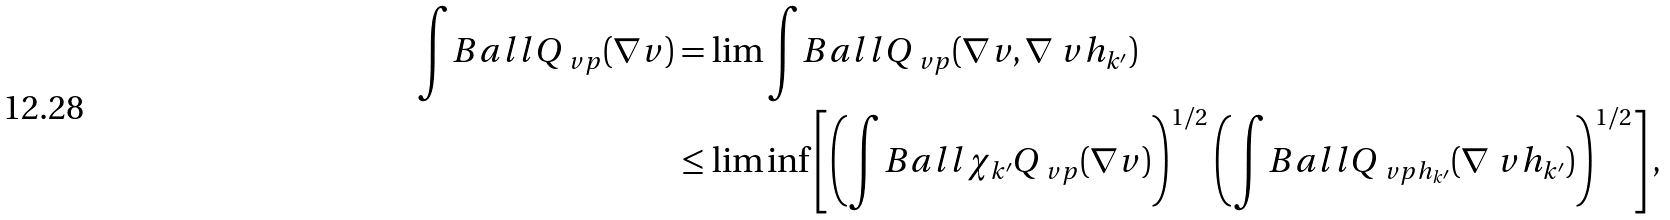<formula> <loc_0><loc_0><loc_500><loc_500>\int _ { \ } B a l l Q _ { \ v p } ( \nabla v ) & = \lim \int _ { \ } B a l l Q _ { \ v p } ( \nabla v , \nabla \ v h _ { k ^ { \prime } } ) \\ & \leq \liminf \left [ \left ( \int _ { \ } B a l l \chi _ { k ^ { \prime } } Q _ { \ v p } ( \nabla v ) \right ) ^ { 1 / 2 } \left ( \int _ { \ } B a l l Q _ { \ v p h _ { k ^ { \prime } } } ( \nabla \ v h _ { k ^ { \prime } } ) \right ) ^ { 1 / 2 } \right ] ,</formula> 